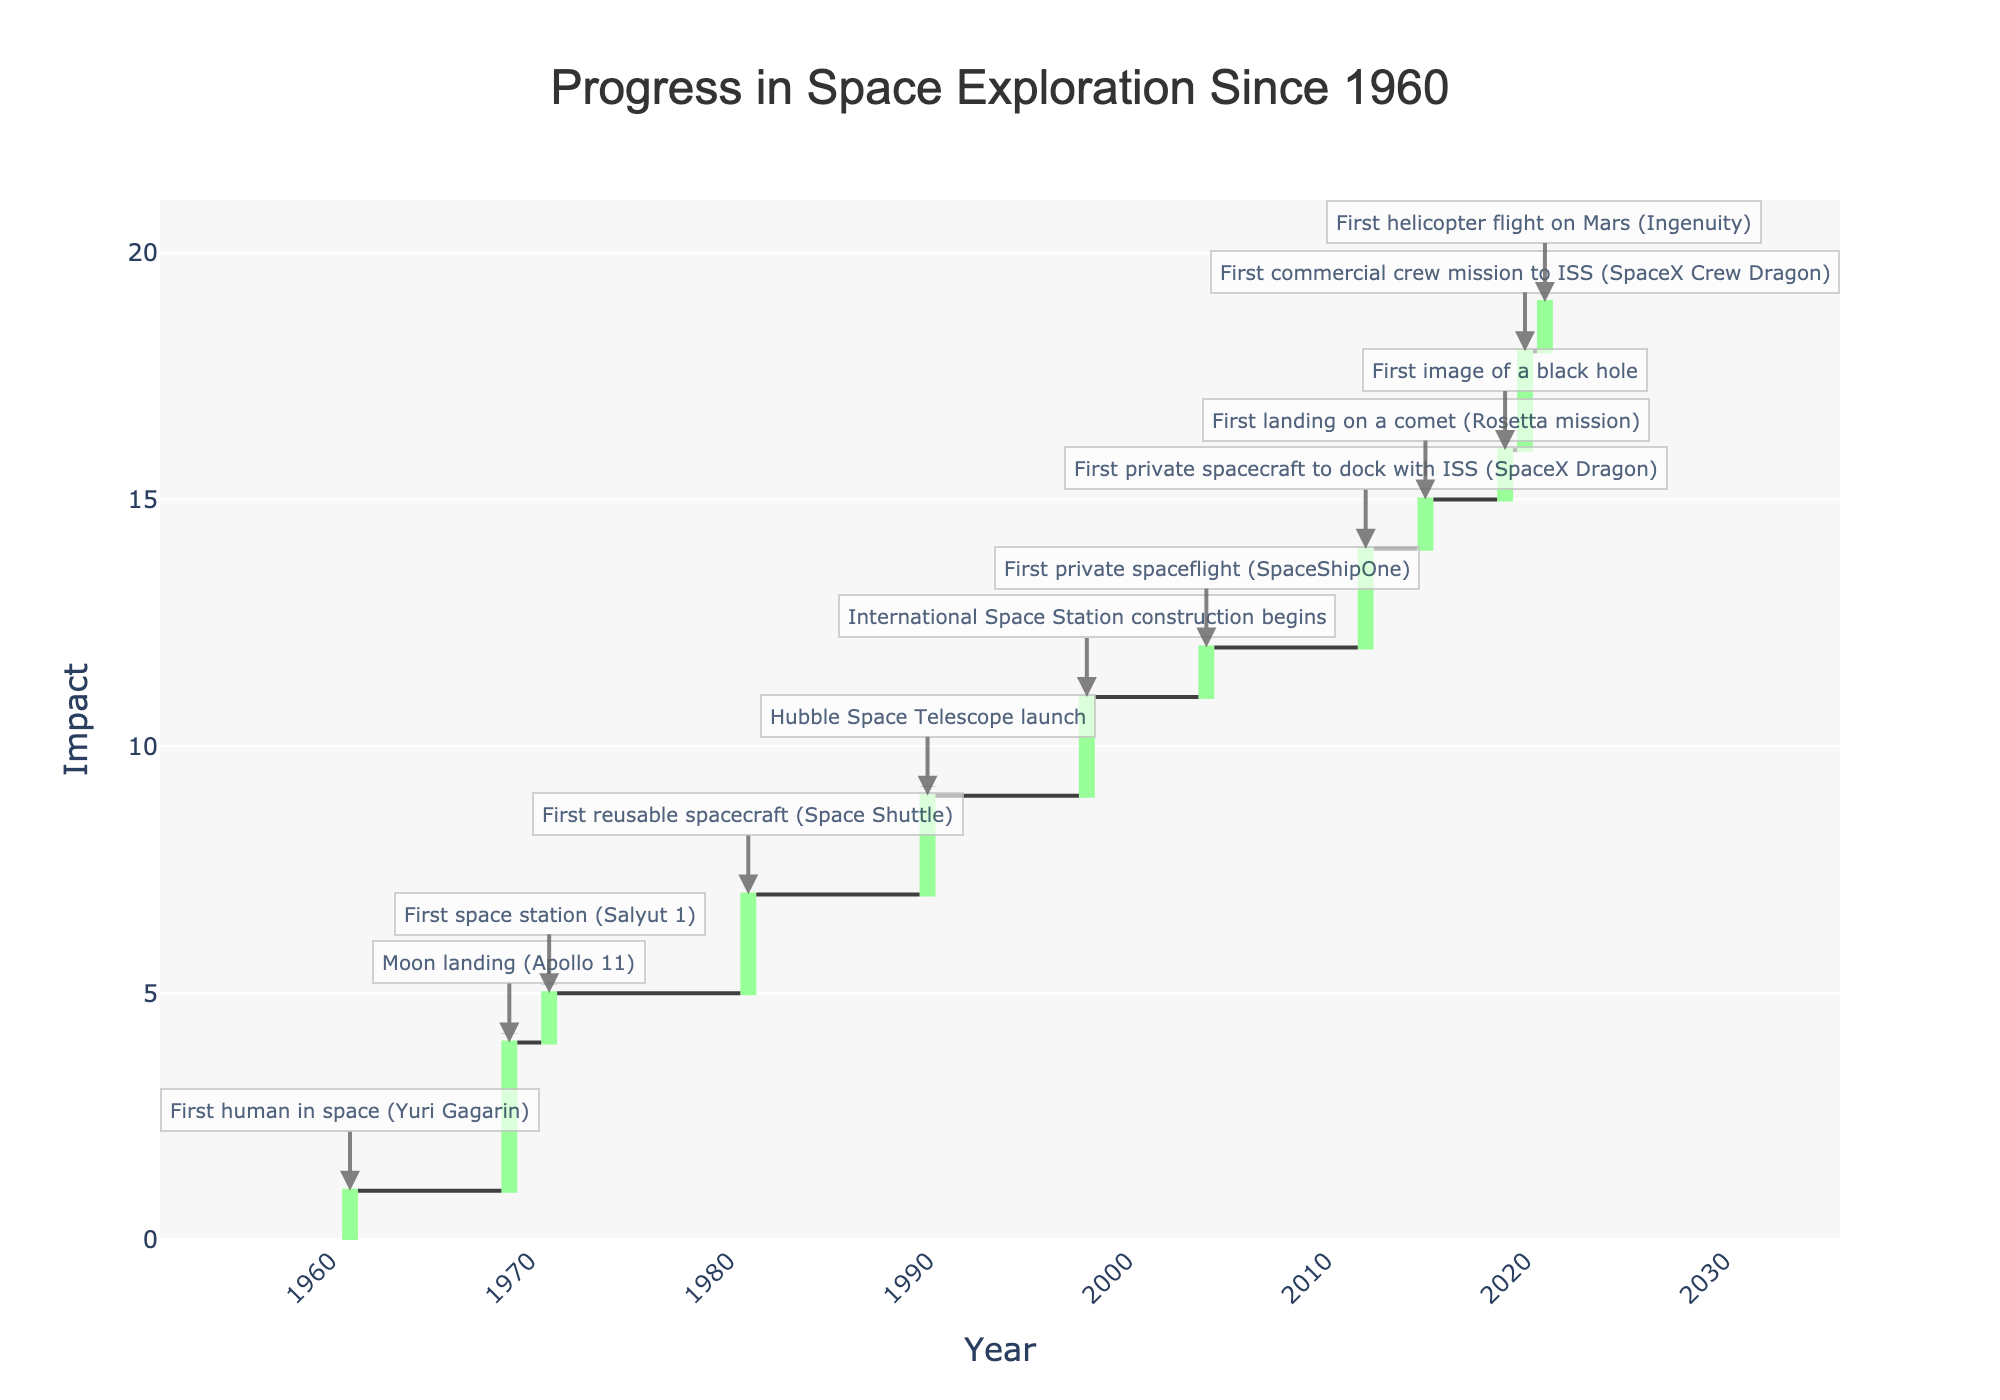What's the title of the figure? The title of the figure is usually prominently displayed at the top of the chart. It gives a brief understanding of what the chart is about. In this figure, it reads "Progress in Space Exploration Since 1960"
Answer: Progress in Space Exploration Since 1960 How many total space exploration milestones are highlighted in the figure? To determine the number of milestones, all you need to do is count each event listed on the x-axis. Based on the data provided, there are 12 events.
Answer: 12 Which event had the highest impact on space exploration according to the chart? To find the event with the highest impact, examine the y-axis values for the given milestones. The event with the highest number (3) is the "Moon landing (Apollo 11)" in 1969.
Answer: Moon landing (Apollo 11) What is the cumulative impact of space exploration milestones by the year 2012? To find the cumulative impact by 2012, you sum up the impacts from the milestones up to that year. The impacts are 1 (1961), 3 (1969), 1 (1971), 2 (1981), 2 (1990), 2 (1998), 1 (2004), and 2 (2012), which adds up to 14.
Answer: 14 Which milestone contributed the least to the cumulative impact after 1980? To determine the least impactful event after 1980, look at the events listed post-1980 and compare their impact values. The events are the Hubble Space Telescope launch (1990, impact 2), ISS construction begins (1998, impact 2), SpaceShipOne (2004, impact 1), SpaceX Dragon (2012, impact 2), Rosetta mission (2015, impact 1), the black hole image (2019, impact 1), commercial crew mission to ISS (2020, impact 2), and helicopter flight on Mars (2021, impact 1).  The event with the lowest impact is "First private spaceflight (SpaceShipOne)" in 2004 and "First landing on a comet (Rosetta mission)" in 2015 and "First image of a black hole" in 2019 and "First helicopter flight on Mars (Ingenuity)" in 2021 which have an impact value of 1.
Answer: First private spaceflight (SpaceShipOne) in 2004, First landing on a comet (Rosetta mission) in 2015, First image of a black hole in 2019, and first helicopter flight on Mars (Ingenuity) in 2021 What are the first and last milestones shown in this chart? To identify the first and last milestones, look at the earliest and latest years listed on the x-axis. The first milestone is "First human in space (Yuri Gagarin)" in 1961 and the last milestone is "First helicopter flight on Mars (Ingenuity)" in 2021.
Answer: First human in space (Yuri Gagarin), First helicopter flight on Mars (Ingenuity) Which decade had the most significant impact on space exploration according to the chart? To determine the most impactful decade, sum the impact values of milestones within each decade. The 1960s (1+3) equal 4 impact points, 1970s (1) equals 1 impact point, 1980s (2) equals 2 impact points, 1990s (2+2) equal 4 impact points, 2000s (1+2) equal 3 impact points, and 2010s (2+1+1) equal 4 impact points. There is a tie between the 1960s, 1990s, and 2010s, each with a total impact of 4.
Answer: 1960s, 1990s, 2010s (tie) What milestone is associated with the first use of a reusable spacecraft? Find the milestone connected with a reusable spacecraft by searching through the descriptions of the events. The milestone is "First reusable spacecraft (Space Shuttle)," which occurred in 1981.
Answer: First reusable spacecraft (Space Shuttle) Which two events both have the same impact value of 2 and are closest in time to each other? To answer this, identify all events with an impact value of 2 and then find the two closest in years. The events are "First reusable spacecraft (Space Shuttle)" in 1981 and "Hubble Space Telescope launch" in 1990 with a gap of 9 years.
Answer: First reusable spacecraft (Space Shuttle) and Hubble Space Telescope launch 